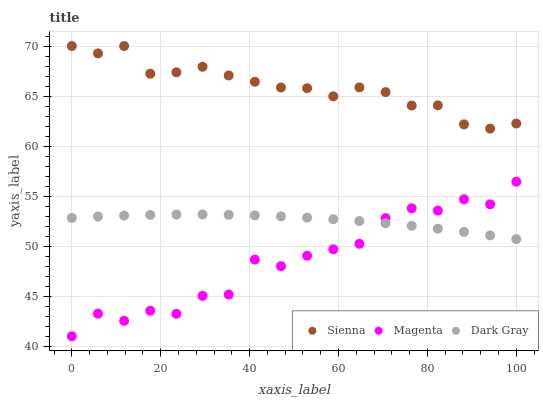Does Magenta have the minimum area under the curve?
Answer yes or no. Yes. Does Sienna have the maximum area under the curve?
Answer yes or no. Yes. Does Dark Gray have the minimum area under the curve?
Answer yes or no. No. Does Dark Gray have the maximum area under the curve?
Answer yes or no. No. Is Dark Gray the smoothest?
Answer yes or no. Yes. Is Magenta the roughest?
Answer yes or no. Yes. Is Magenta the smoothest?
Answer yes or no. No. Is Dark Gray the roughest?
Answer yes or no. No. Does Magenta have the lowest value?
Answer yes or no. Yes. Does Dark Gray have the lowest value?
Answer yes or no. No. Does Sienna have the highest value?
Answer yes or no. Yes. Does Magenta have the highest value?
Answer yes or no. No. Is Dark Gray less than Sienna?
Answer yes or no. Yes. Is Sienna greater than Magenta?
Answer yes or no. Yes. Does Magenta intersect Dark Gray?
Answer yes or no. Yes. Is Magenta less than Dark Gray?
Answer yes or no. No. Is Magenta greater than Dark Gray?
Answer yes or no. No. Does Dark Gray intersect Sienna?
Answer yes or no. No. 